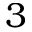Convert formula to latex. <formula><loc_0><loc_0><loc_500><loc_500>3</formula> 